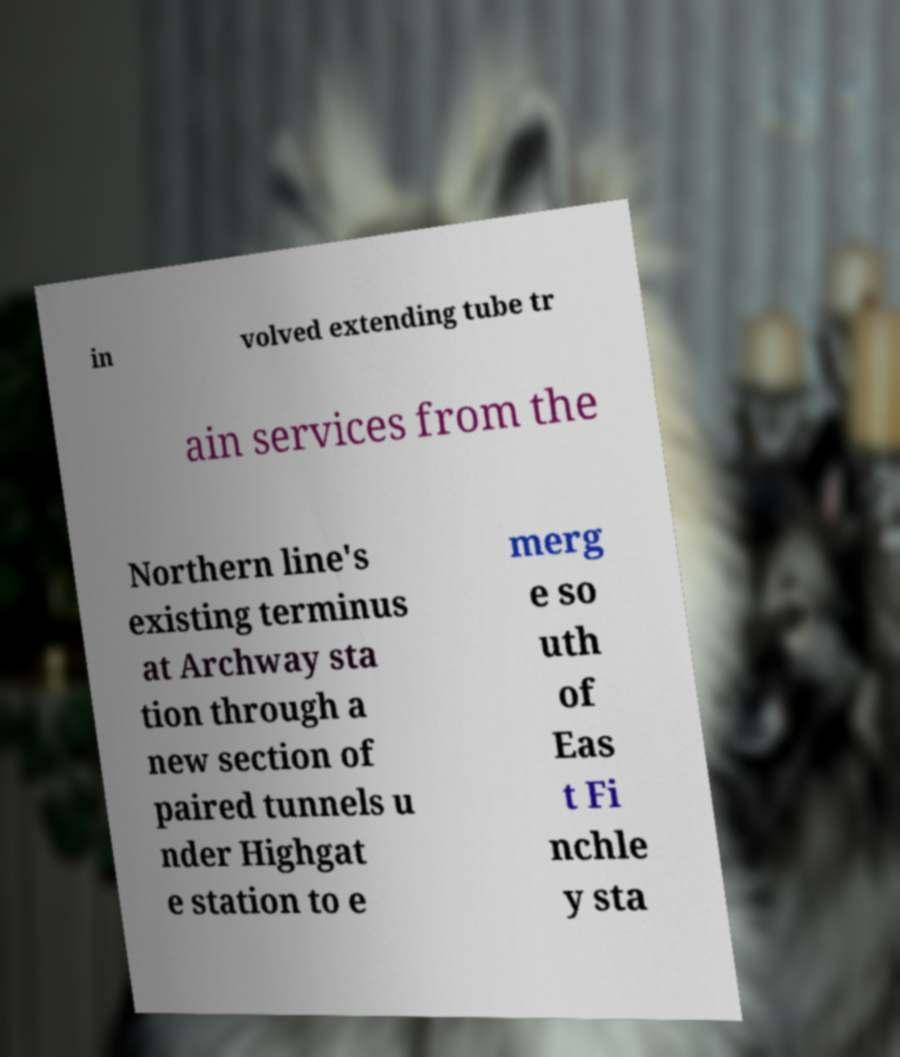There's text embedded in this image that I need extracted. Can you transcribe it verbatim? in volved extending tube tr ain services from the Northern line's existing terminus at Archway sta tion through a new section of paired tunnels u nder Highgat e station to e merg e so uth of Eas t Fi nchle y sta 